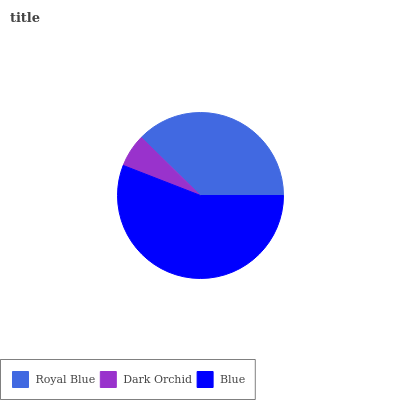Is Dark Orchid the minimum?
Answer yes or no. Yes. Is Blue the maximum?
Answer yes or no. Yes. Is Blue the minimum?
Answer yes or no. No. Is Dark Orchid the maximum?
Answer yes or no. No. Is Blue greater than Dark Orchid?
Answer yes or no. Yes. Is Dark Orchid less than Blue?
Answer yes or no. Yes. Is Dark Orchid greater than Blue?
Answer yes or no. No. Is Blue less than Dark Orchid?
Answer yes or no. No. Is Royal Blue the high median?
Answer yes or no. Yes. Is Royal Blue the low median?
Answer yes or no. Yes. Is Blue the high median?
Answer yes or no. No. Is Blue the low median?
Answer yes or no. No. 